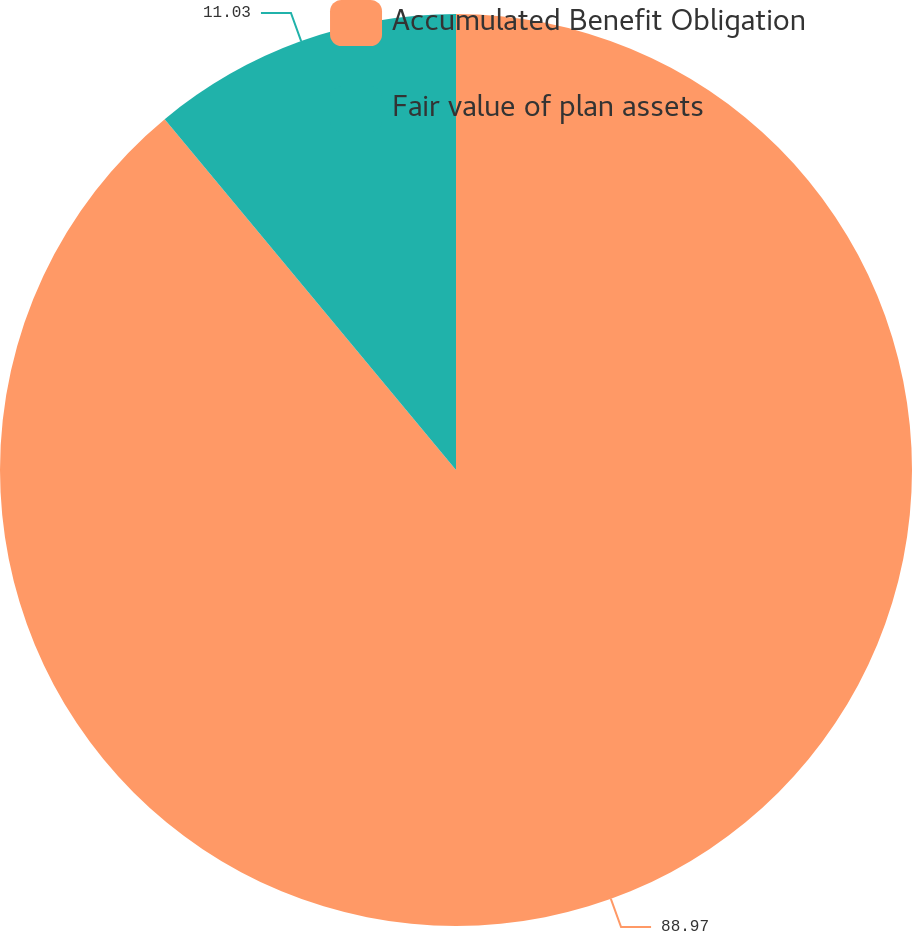Convert chart. <chart><loc_0><loc_0><loc_500><loc_500><pie_chart><fcel>Accumulated Benefit Obligation<fcel>Fair value of plan assets<nl><fcel>88.97%<fcel>11.03%<nl></chart> 